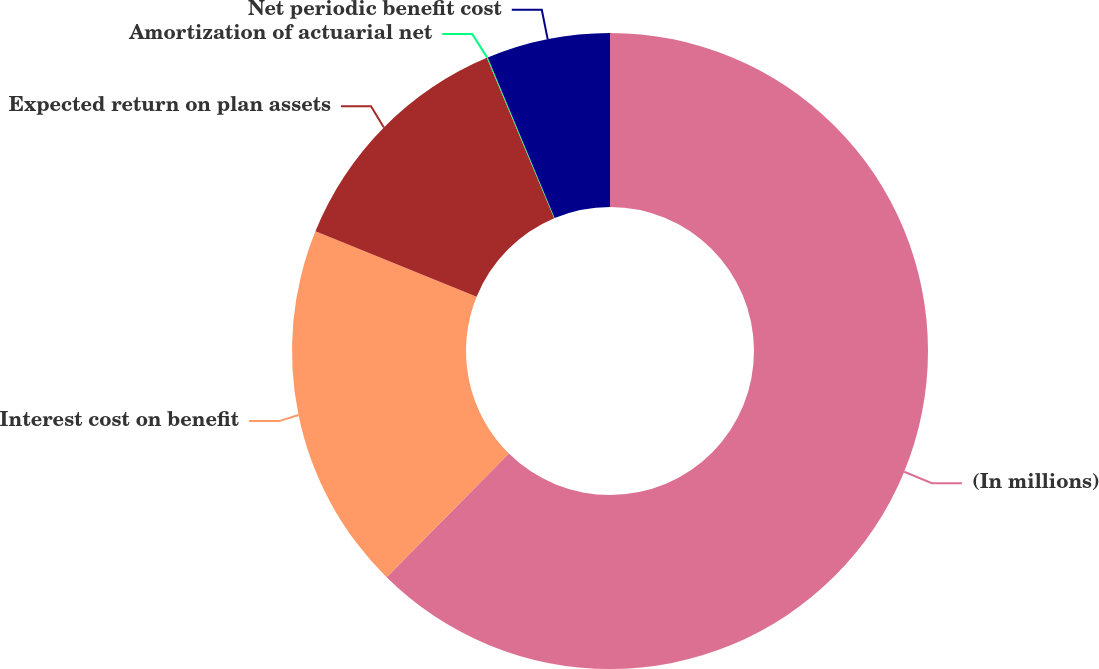<chart> <loc_0><loc_0><loc_500><loc_500><pie_chart><fcel>(In millions)<fcel>Interest cost on benefit<fcel>Expected return on plan assets<fcel>Amortization of actuarial net<fcel>Net periodic benefit cost<nl><fcel>62.39%<fcel>18.75%<fcel>12.52%<fcel>0.05%<fcel>6.28%<nl></chart> 